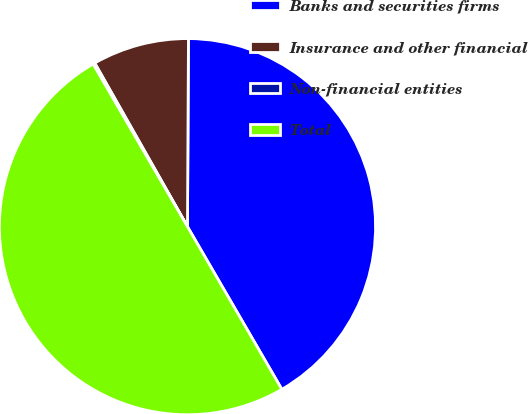<chart> <loc_0><loc_0><loc_500><loc_500><pie_chart><fcel>Banks and securities firms<fcel>Insurance and other financial<fcel>Non-financial entities<fcel>Total<nl><fcel>41.55%<fcel>8.29%<fcel>0.16%<fcel>50.0%<nl></chart> 